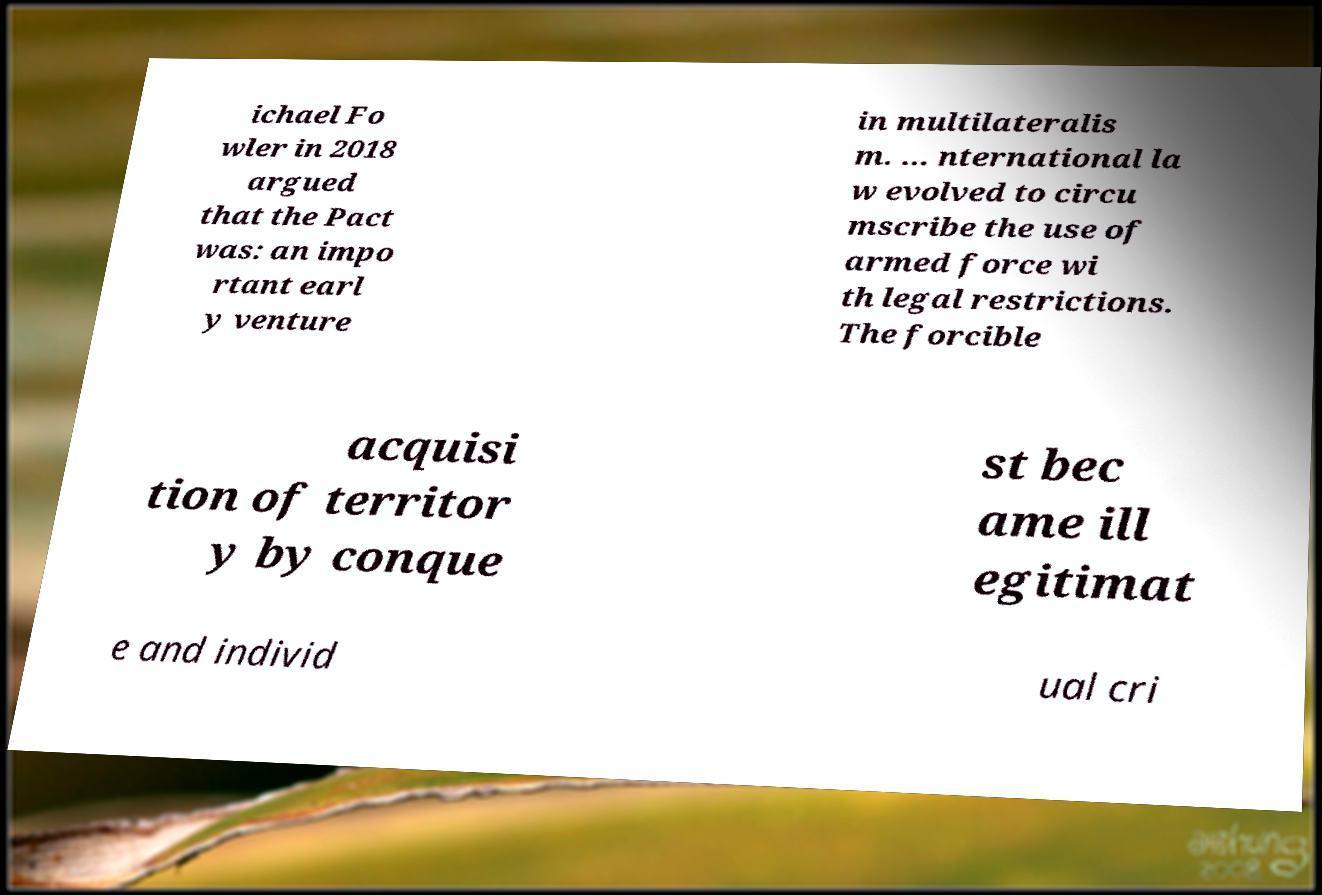What messages or text are displayed in this image? I need them in a readable, typed format. ichael Fo wler in 2018 argued that the Pact was: an impo rtant earl y venture in multilateralis m. ... nternational la w evolved to circu mscribe the use of armed force wi th legal restrictions. The forcible acquisi tion of territor y by conque st bec ame ill egitimat e and individ ual cri 